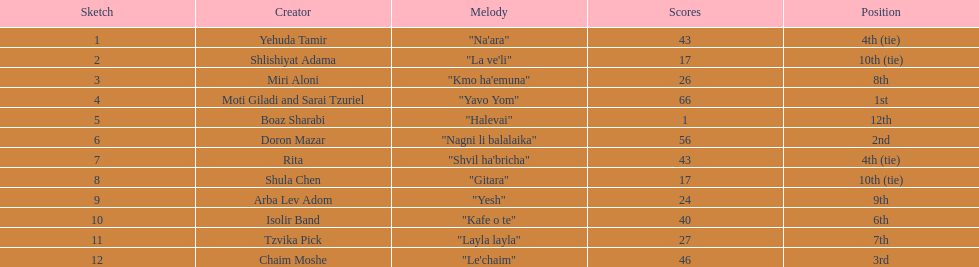What song earned the most points? "Yavo Yom". 